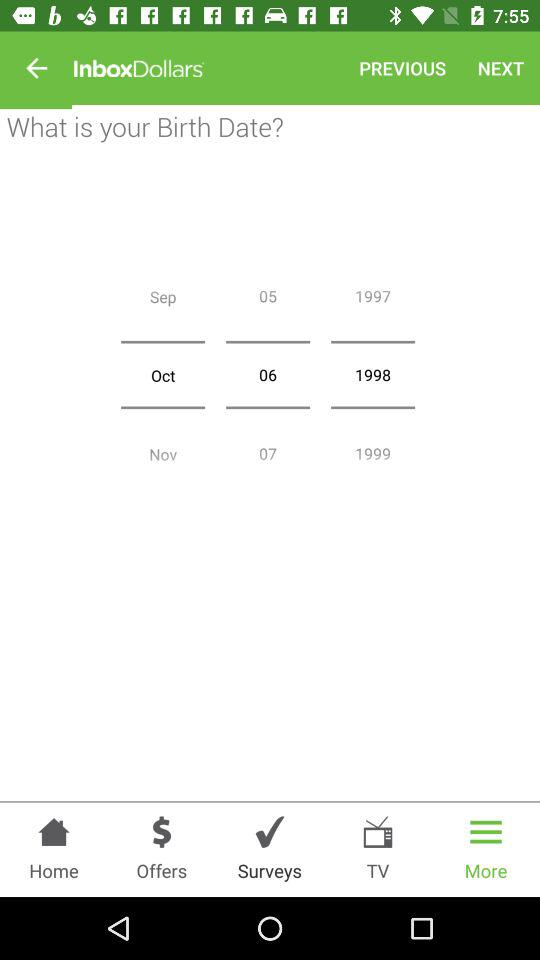What is the year of birth? The year of birth is 1998. 